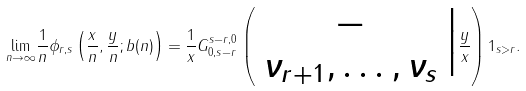Convert formula to latex. <formula><loc_0><loc_0><loc_500><loc_500>\underset { n \rightarrow \infty } { \lim } \frac { 1 } { n } \phi _ { r , s } \left ( \frac { x } { n } , \frac { y } { n } ; b ( n ) \right ) = \frac { 1 } { x } G ^ { s - r , 0 } _ { 0 , s - r } \left ( \begin{array} { c } - \\ \nu _ { r + 1 } , \dots , \nu _ { s } \end{array} \Big | \frac { y } { x } \right ) 1 _ { s > r } .</formula> 